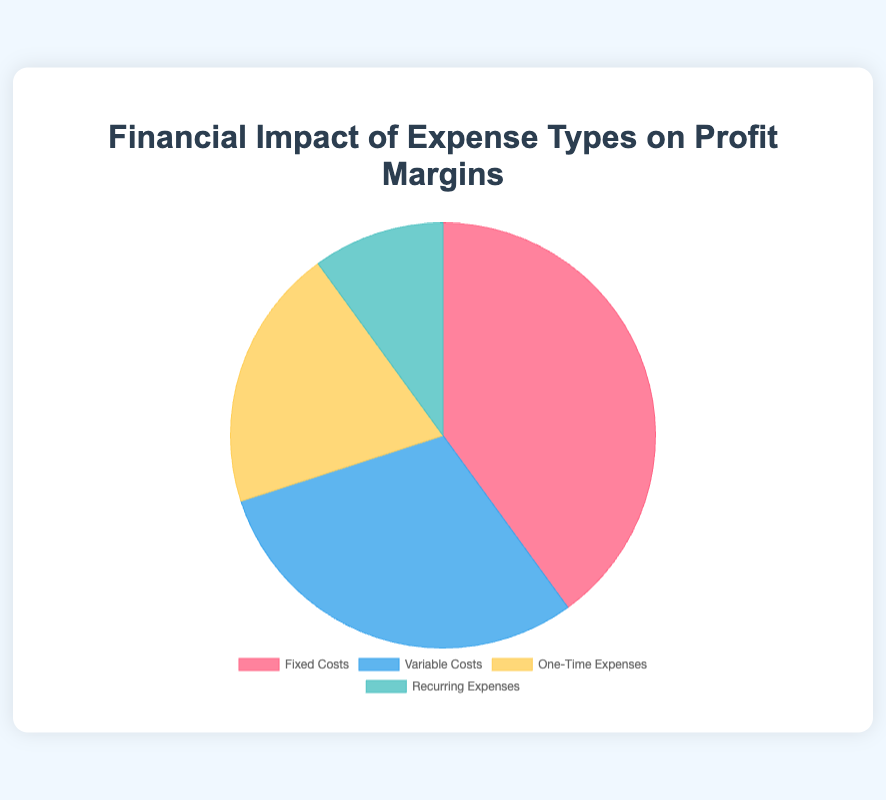Which expense type has the largest financial impact on profit margins? The pie chart shows that the segment labeled "Fixed Costs" occupies the largest portion of the chart.
Answer: Fixed Costs How much greater is the financial impact of variable costs compared to recurring expenses? The pie chart data indicates that variable costs impact profit margins by 30%, whereas recurring expenses impact by 10%. The difference is 30% - 10% = 20%.
Answer: 20% If we combine the financial impact of fixed costs and one-time expenses, what percentage of the total profit margin do they constitute? The financial impacts of fixed costs and one-time expenses are 40% and 20% respectively. Adding them gives 40% + 20% = 60%.
Answer: 60% Which two expense types together have the exact same financial impact as fixed costs alone? Fixed costs have a financial impact of 40%. The sum of the financial impacts of one-time expenses (20%) and recurring expenses (10%) is 20% + 10% = 30%. Therefore, one-time and recurring expenses together (30%) do not match fixed costs alone. However, variable costs (30%) and recurring expenses (10%) together make 30% + 10% = 40%, matching the fixed costs.
Answer: Variable Costs and Recurring Expenses What is the total financial impact of variable costs and one-time expenses combined? Variable costs impact profit margins by 30% while one-time expenses impact by 20%. Adding them gives 30% + 20% = 50%.
Answer: 50% Which expense type has the least financial impact on profit margins? The pie chart shows that the smallest segment is the one labeled "Recurring Expenses".
Answer: Recurring Expenses How does the financial impact of fixed costs compare to the combined impact of variable costs and recurring expenses? Fixed costs impact profit margins by 40%, while the combined impact of variable costs (30%) and recurring expenses (10%) is 30% + 10% = 40%. Therefore, they are equal.
Answer: Equal Which segment in the pie chart is represented in blue? The pie chart description mentions that the blue color corresponds to "Variable Costs".
Answer: Variable Costs What is the difference in financial impact between the expense type with the highest impact and the one with the lowest impact? The highest impact expense type is fixed costs at 40%, while the lowest is recurring expenses at 10%. The difference is 40% - 10% = 30%.
Answer: 30% 